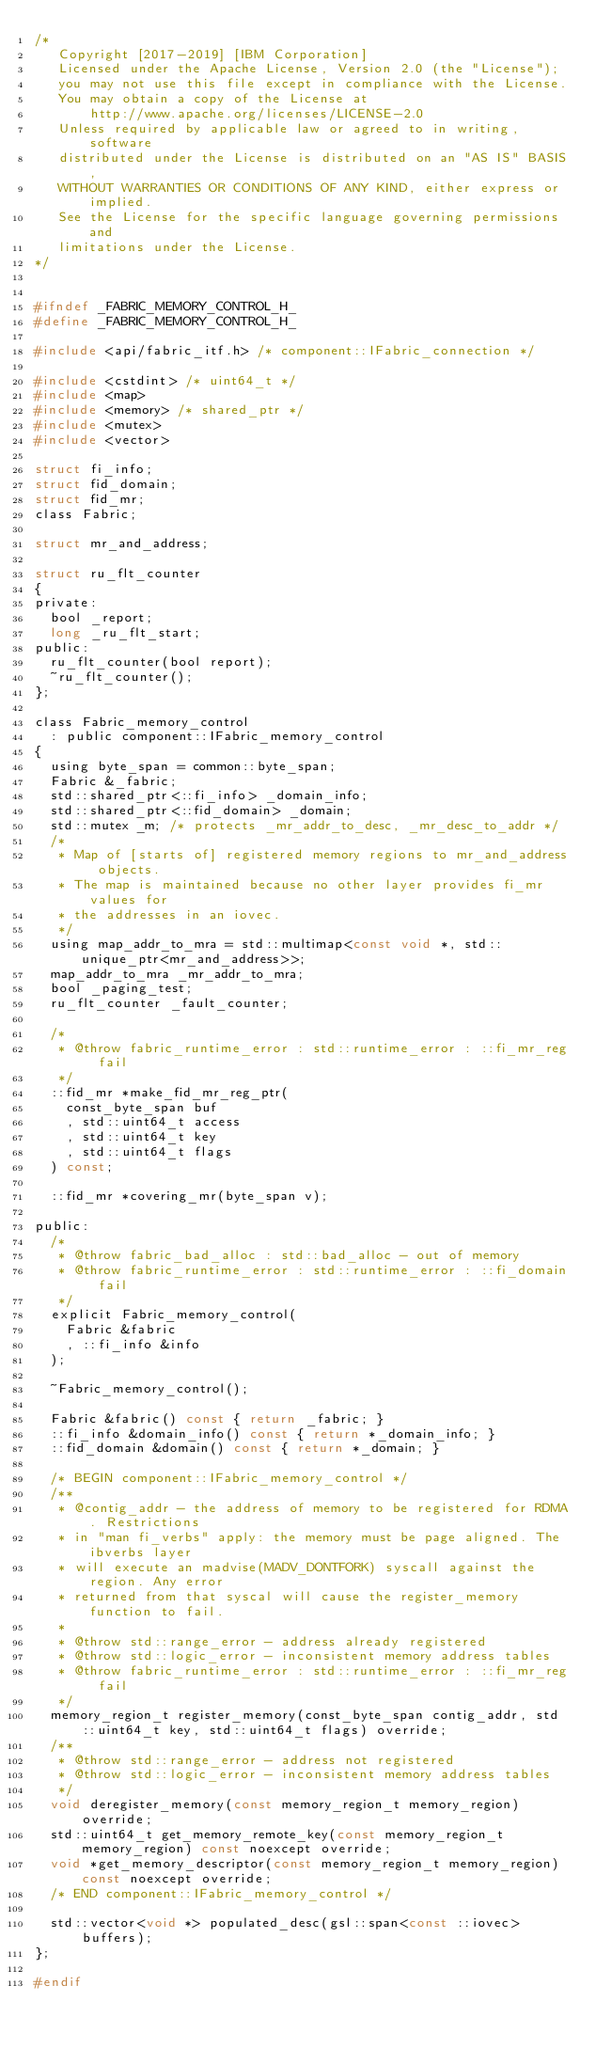<code> <loc_0><loc_0><loc_500><loc_500><_C_>/*
   Copyright [2017-2019] [IBM Corporation]
   Licensed under the Apache License, Version 2.0 (the "License");
   you may not use this file except in compliance with the License.
   You may obtain a copy of the License at
       http://www.apache.org/licenses/LICENSE-2.0
   Unless required by applicable law or agreed to in writing, software
   distributed under the License is distributed on an "AS IS" BASIS,
   WITHOUT WARRANTIES OR CONDITIONS OF ANY KIND, either express or implied.
   See the License for the specific language governing permissions and
   limitations under the License.
*/


#ifndef _FABRIC_MEMORY_CONTROL_H_
#define _FABRIC_MEMORY_CONTROL_H_

#include <api/fabric_itf.h> /* component::IFabric_connection */

#include <cstdint> /* uint64_t */
#include <map>
#include <memory> /* shared_ptr */
#include <mutex>
#include <vector>

struct fi_info;
struct fid_domain;
struct fid_mr;
class Fabric;

struct mr_and_address;

struct ru_flt_counter
{
private:
  bool _report;
  long _ru_flt_start;
public:
  ru_flt_counter(bool report);
  ~ru_flt_counter();
};

class Fabric_memory_control
  : public component::IFabric_memory_control
{
  using byte_span = common::byte_span;
  Fabric &_fabric;
  std::shared_ptr<::fi_info> _domain_info;
  std::shared_ptr<::fid_domain> _domain;
  std::mutex _m; /* protects _mr_addr_to_desc, _mr_desc_to_addr */
  /*
   * Map of [starts of] registered memory regions to mr_and_address objects.
   * The map is maintained because no other layer provides fi_mr values for
   * the addresses in an iovec.
   */
  using map_addr_to_mra = std::multimap<const void *, std::unique_ptr<mr_and_address>>;
  map_addr_to_mra _mr_addr_to_mra;
  bool _paging_test;
  ru_flt_counter _fault_counter;

  /*
   * @throw fabric_runtime_error : std::runtime_error : ::fi_mr_reg fail
   */
  ::fid_mr *make_fid_mr_reg_ptr(
    const_byte_span buf
    , std::uint64_t access
    , std::uint64_t key
    , std::uint64_t flags
  ) const;

  ::fid_mr *covering_mr(byte_span v);

public:
  /*
   * @throw fabric_bad_alloc : std::bad_alloc - out of memory
   * @throw fabric_runtime_error : std::runtime_error : ::fi_domain fail
   */
  explicit Fabric_memory_control(
    Fabric &fabric
    , ::fi_info &info
  );

  ~Fabric_memory_control();

  Fabric &fabric() const { return _fabric; }
  ::fi_info &domain_info() const { return *_domain_info; }
  ::fid_domain &domain() const { return *_domain; }

  /* BEGIN component::IFabric_memory_control */
  /**
   * @contig_addr - the address of memory to be registered for RDMA. Restrictions
   * in "man fi_verbs" apply: the memory must be page aligned. The ibverbs layer
   * will execute an madvise(MADV_DONTFORK) syscall against the region. Any error
   * returned from that syscal will cause the register_memory function to fail.
   *
   * @throw std::range_error - address already registered
   * @throw std::logic_error - inconsistent memory address tables
   * @throw fabric_runtime_error : std::runtime_error : ::fi_mr_reg fail
   */
  memory_region_t register_memory(const_byte_span contig_addr, std::uint64_t key, std::uint64_t flags) override;
  /**
   * @throw std::range_error - address not registered
   * @throw std::logic_error - inconsistent memory address tables
   */
  void deregister_memory(const memory_region_t memory_region) override;
  std::uint64_t get_memory_remote_key(const memory_region_t memory_region) const noexcept override;
  void *get_memory_descriptor(const memory_region_t memory_region) const noexcept override;
  /* END component::IFabric_memory_control */

  std::vector<void *> populated_desc(gsl::span<const ::iovec> buffers);
};

#endif
</code> 